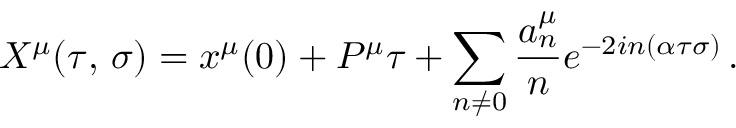<formula> <loc_0><loc_0><loc_500><loc_500>X ^ { \mu } ( \tau , \, \sigma ) = x ^ { \mu } ( 0 ) + P ^ { \mu } \tau + \sum _ { n \ne 0 } \frac { a _ { n } ^ { \mu } } { n } e ^ { - 2 i n ( \alpha \tau \sigma ) } \, .</formula> 